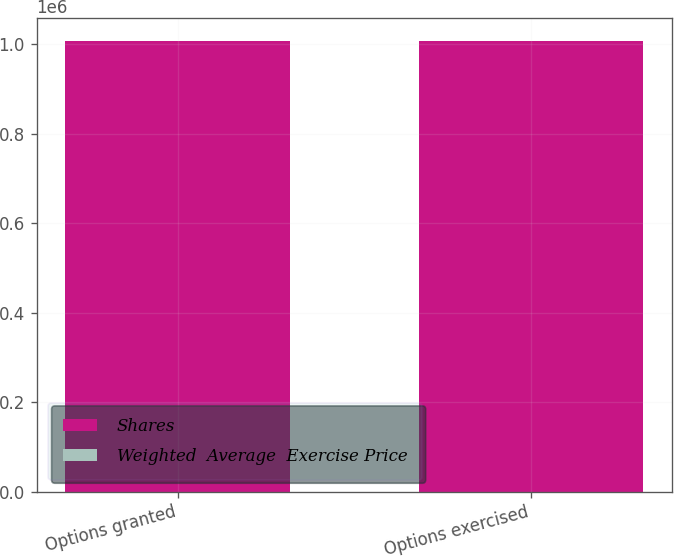Convert chart. <chart><loc_0><loc_0><loc_500><loc_500><stacked_bar_chart><ecel><fcel>Options granted<fcel>Options exercised<nl><fcel>Shares<fcel>1.00767e+06<fcel>1.00767e+06<nl><fcel>Weighted  Average  Exercise Price<fcel>133.52<fcel>133.52<nl></chart> 